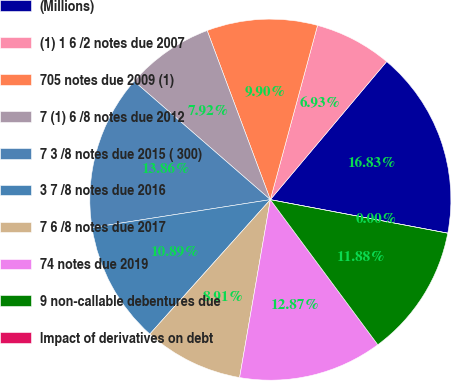Convert chart. <chart><loc_0><loc_0><loc_500><loc_500><pie_chart><fcel>(Millions)<fcel>(1) 1 6 /2 notes due 2007<fcel>705 notes due 2009 (1)<fcel>7 (1) 6 /8 notes due 2012<fcel>7 3 /8 notes due 2015 ( 300)<fcel>3 7 /8 notes due 2016<fcel>7 6 /8 notes due 2017<fcel>74 notes due 2019<fcel>9 non-callable debentures due<fcel>Impact of derivatives on debt<nl><fcel>16.83%<fcel>6.93%<fcel>9.9%<fcel>7.92%<fcel>13.86%<fcel>10.89%<fcel>8.91%<fcel>12.87%<fcel>11.88%<fcel>0.0%<nl></chart> 